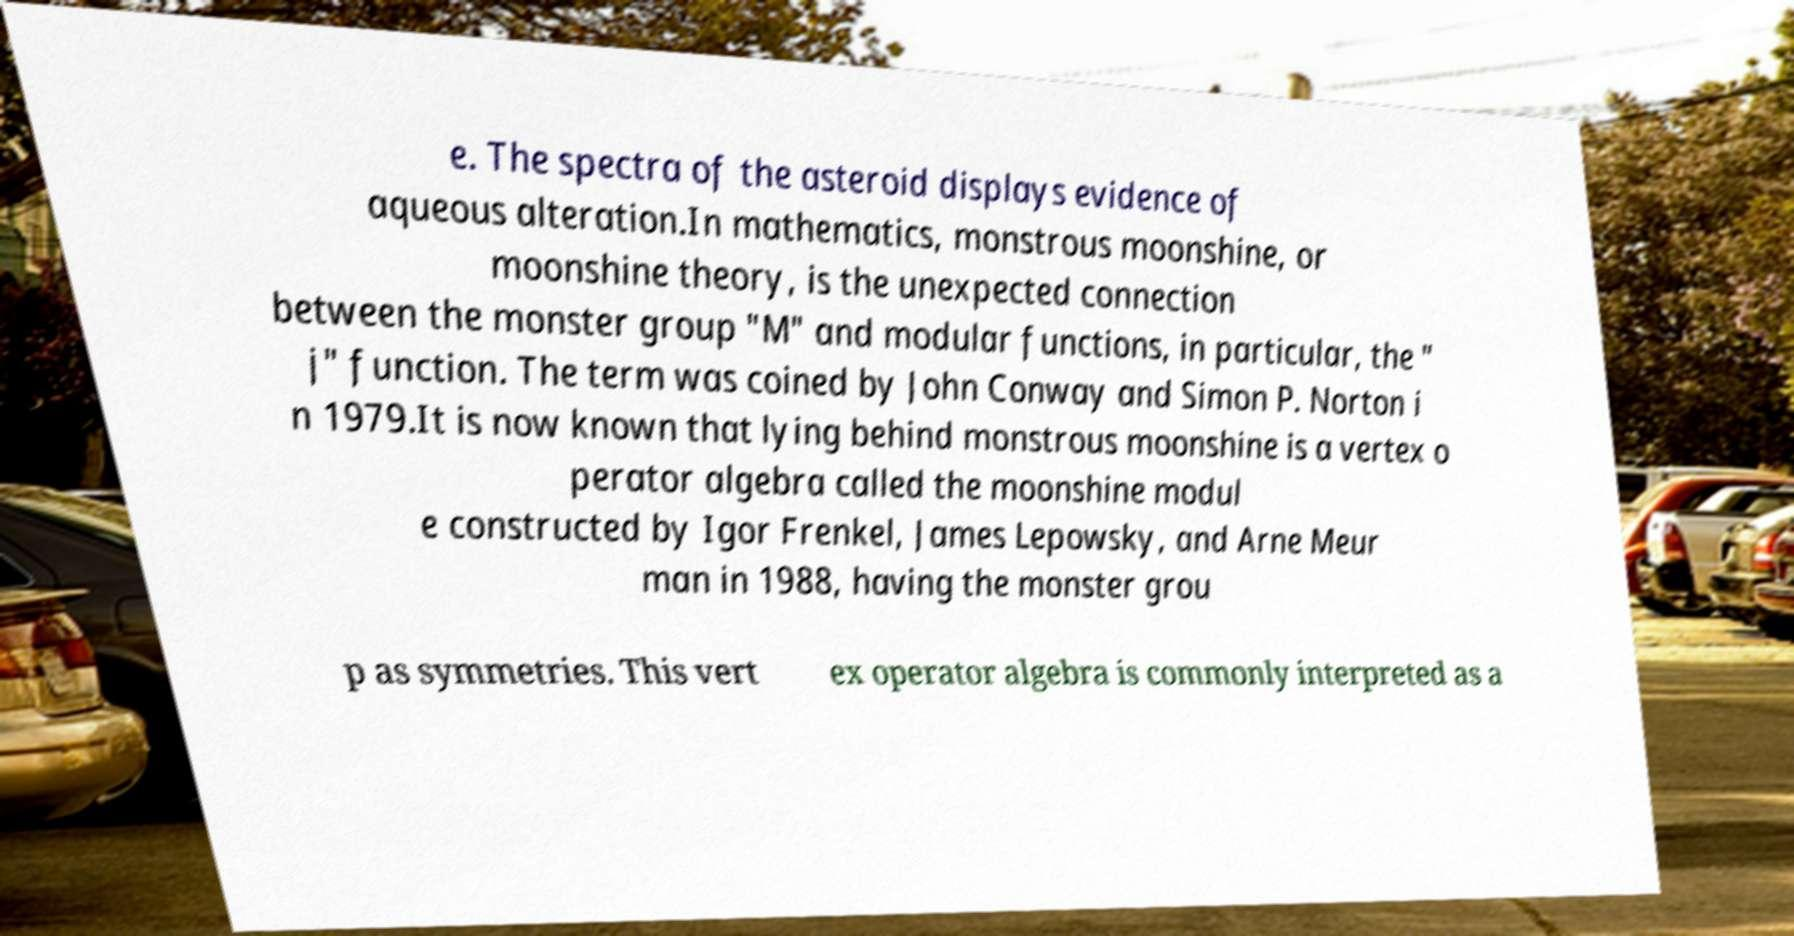I need the written content from this picture converted into text. Can you do that? e. The spectra of the asteroid displays evidence of aqueous alteration.In mathematics, monstrous moonshine, or moonshine theory, is the unexpected connection between the monster group "M" and modular functions, in particular, the " j" function. The term was coined by John Conway and Simon P. Norton i n 1979.It is now known that lying behind monstrous moonshine is a vertex o perator algebra called the moonshine modul e constructed by Igor Frenkel, James Lepowsky, and Arne Meur man in 1988, having the monster grou p as symmetries. This vert ex operator algebra is commonly interpreted as a 